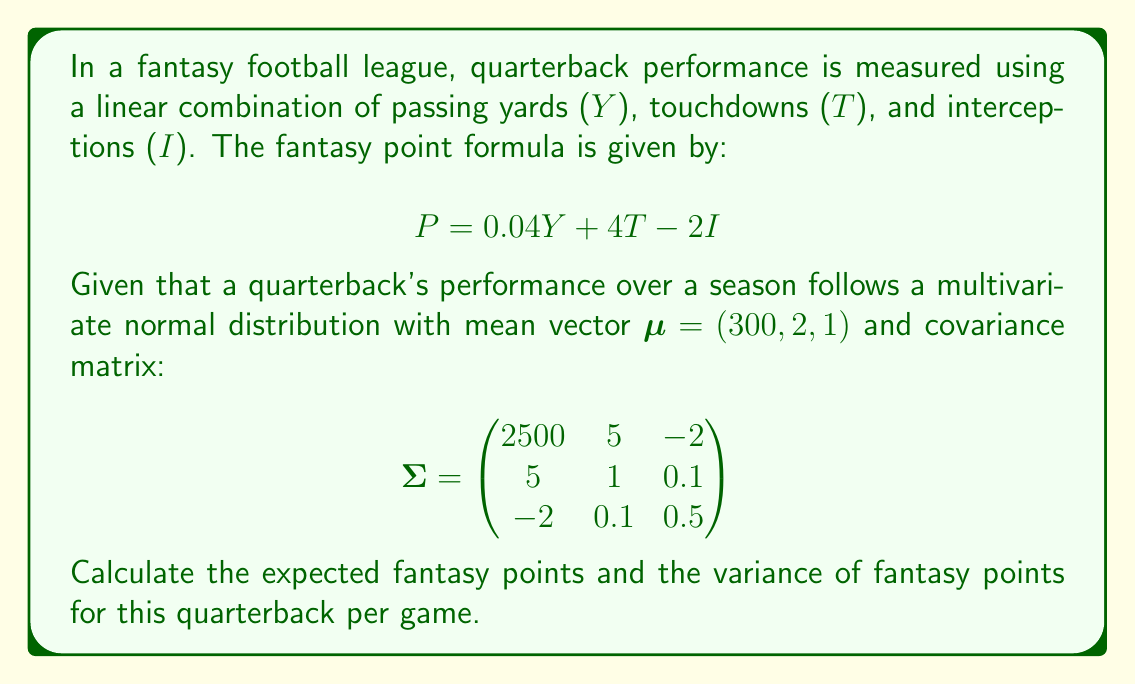Show me your answer to this math problem. To solve this problem, we'll use properties of linear combinations of random variables and the multivariate normal distribution.

Step 1: Expected fantasy points
The expected value of a linear combination of random variables is the linear combination of their expected values. So:

$$E[P] = 0.04E[Y] + 4E[T] - 2E[I]$$

Given $\mu = (300, 2, 1)$, we have:
$$E[P] = 0.04(300) + 4(2) - 2(1) = 12 + 8 - 2 = 18$$

Step 2: Variance of fantasy points
For the variance, we use the formula for the variance of a linear combination of correlated random variables:

$$Var(P) = a^T\Sigma a$$

where $a = (0.04, 4, -2)$ is the vector of coefficients.

Expanding this:
$$\begin{align}
Var(P) &= (0.04, 4, -2) \begin{pmatrix}
2500 & 5 & -2 \\
5 & 1 & 0.1 \\
-2 & 0.1 & 0.5
\end{pmatrix} \begin{pmatrix}0.04 \\ 4 \\ -2\end{pmatrix} \\
&= (0.04(2500) + 4(5) + (-2)(-2), \\
   &\quad 0.04(5) + 4(1) + (-2)(0.1), \\
   &\quad 0.04(-2) + 4(0.1) + (-2)(0.5)) \begin{pmatrix}0.04 \\ 4 \\ -2\end{pmatrix} \\
&= (100 + 20 + 4, 0.2 + 4 - 0.2, -0.08 + 0.4 - 1) \begin{pmatrix}0.04 \\ 4 \\ -2\end{pmatrix} \\
&= (124, 4, -0.68) \begin{pmatrix}0.04 \\ 4 \\ -2\end{pmatrix} \\
&= 4.96 + 16 + 1.36 \\
&= 22.32
\end{align}$$
Answer: $E[P] = 18$, $Var(P) = 22.32$ 